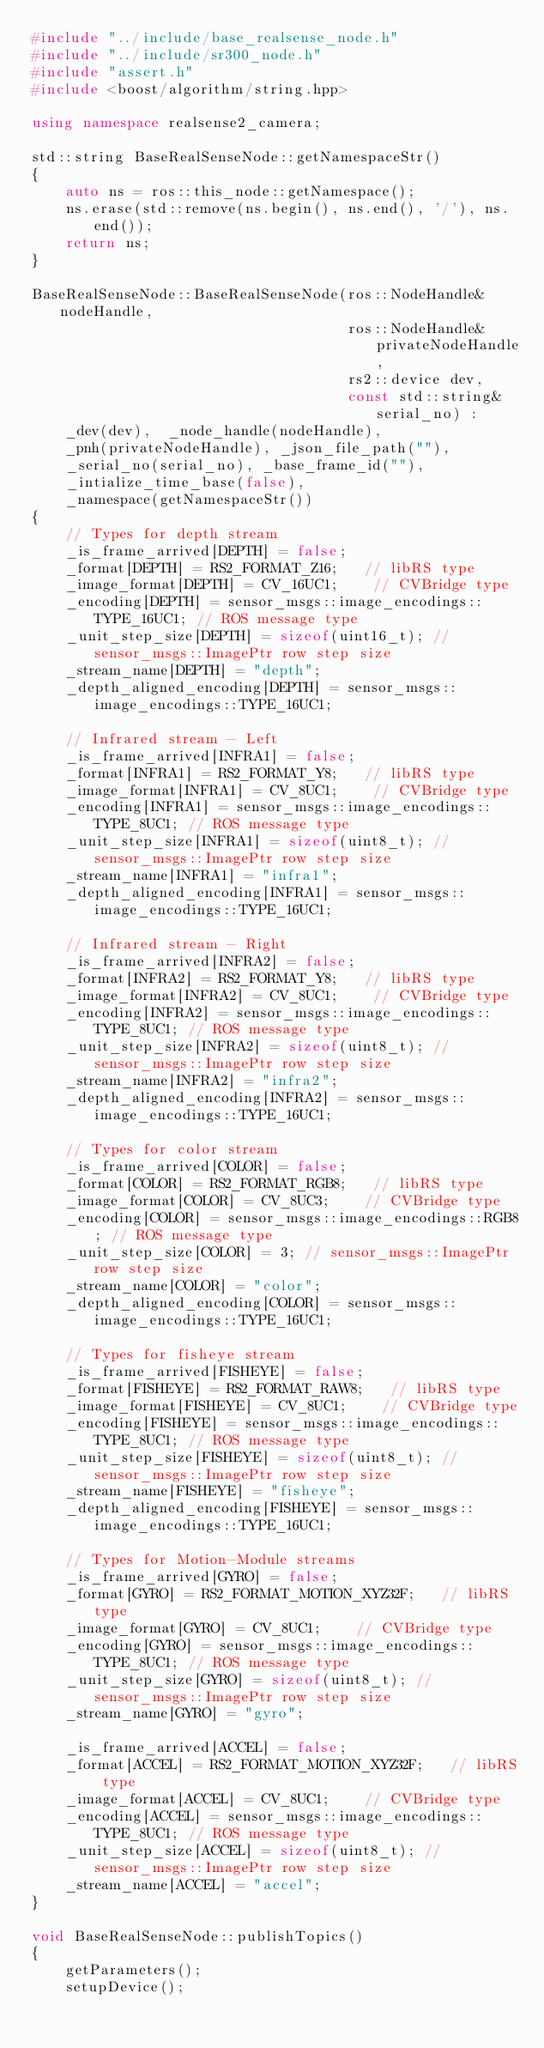<code> <loc_0><loc_0><loc_500><loc_500><_C++_>#include "../include/base_realsense_node.h"
#include "../include/sr300_node.h"
#include "assert.h"
#include <boost/algorithm/string.hpp>

using namespace realsense2_camera;

std::string BaseRealSenseNode::getNamespaceStr()
{
    auto ns = ros::this_node::getNamespace();
    ns.erase(std::remove(ns.begin(), ns.end(), '/'), ns.end());
    return ns;
}

BaseRealSenseNode::BaseRealSenseNode(ros::NodeHandle& nodeHandle,
                                     ros::NodeHandle& privateNodeHandle,
                                     rs2::device dev,
                                     const std::string& serial_no) :
    _dev(dev),  _node_handle(nodeHandle),
    _pnh(privateNodeHandle), _json_file_path(""),
    _serial_no(serial_no), _base_frame_id(""),
    _intialize_time_base(false),
    _namespace(getNamespaceStr())
{
    // Types for depth stream
    _is_frame_arrived[DEPTH] = false;
    _format[DEPTH] = RS2_FORMAT_Z16;   // libRS type
    _image_format[DEPTH] = CV_16UC1;    // CVBridge type
    _encoding[DEPTH] = sensor_msgs::image_encodings::TYPE_16UC1; // ROS message type
    _unit_step_size[DEPTH] = sizeof(uint16_t); // sensor_msgs::ImagePtr row step size
    _stream_name[DEPTH] = "depth";
    _depth_aligned_encoding[DEPTH] = sensor_msgs::image_encodings::TYPE_16UC1;

    // Infrared stream - Left
    _is_frame_arrived[INFRA1] = false;
    _format[INFRA1] = RS2_FORMAT_Y8;   // libRS type
    _image_format[INFRA1] = CV_8UC1;    // CVBridge type
    _encoding[INFRA1] = sensor_msgs::image_encodings::TYPE_8UC1; // ROS message type
    _unit_step_size[INFRA1] = sizeof(uint8_t); // sensor_msgs::ImagePtr row step size
    _stream_name[INFRA1] = "infra1";
    _depth_aligned_encoding[INFRA1] = sensor_msgs::image_encodings::TYPE_16UC1;

    // Infrared stream - Right
    _is_frame_arrived[INFRA2] = false;
    _format[INFRA2] = RS2_FORMAT_Y8;   // libRS type
    _image_format[INFRA2] = CV_8UC1;    // CVBridge type
    _encoding[INFRA2] = sensor_msgs::image_encodings::TYPE_8UC1; // ROS message type
    _unit_step_size[INFRA2] = sizeof(uint8_t); // sensor_msgs::ImagePtr row step size
    _stream_name[INFRA2] = "infra2";
    _depth_aligned_encoding[INFRA2] = sensor_msgs::image_encodings::TYPE_16UC1;

    // Types for color stream
    _is_frame_arrived[COLOR] = false;
    _format[COLOR] = RS2_FORMAT_RGB8;   // libRS type
    _image_format[COLOR] = CV_8UC3;    // CVBridge type
    _encoding[COLOR] = sensor_msgs::image_encodings::RGB8; // ROS message type
    _unit_step_size[COLOR] = 3; // sensor_msgs::ImagePtr row step size
    _stream_name[COLOR] = "color";
    _depth_aligned_encoding[COLOR] = sensor_msgs::image_encodings::TYPE_16UC1;

    // Types for fisheye stream
    _is_frame_arrived[FISHEYE] = false;
    _format[FISHEYE] = RS2_FORMAT_RAW8;   // libRS type
    _image_format[FISHEYE] = CV_8UC1;    // CVBridge type
    _encoding[FISHEYE] = sensor_msgs::image_encodings::TYPE_8UC1; // ROS message type
    _unit_step_size[FISHEYE] = sizeof(uint8_t); // sensor_msgs::ImagePtr row step size
    _stream_name[FISHEYE] = "fisheye";
    _depth_aligned_encoding[FISHEYE] = sensor_msgs::image_encodings::TYPE_16UC1;

    // Types for Motion-Module streams
    _is_frame_arrived[GYRO] = false;
    _format[GYRO] = RS2_FORMAT_MOTION_XYZ32F;   // libRS type
    _image_format[GYRO] = CV_8UC1;    // CVBridge type
    _encoding[GYRO] = sensor_msgs::image_encodings::TYPE_8UC1; // ROS message type
    _unit_step_size[GYRO] = sizeof(uint8_t); // sensor_msgs::ImagePtr row step size
    _stream_name[GYRO] = "gyro";

    _is_frame_arrived[ACCEL] = false;
    _format[ACCEL] = RS2_FORMAT_MOTION_XYZ32F;   // libRS type
    _image_format[ACCEL] = CV_8UC1;    // CVBridge type
    _encoding[ACCEL] = sensor_msgs::image_encodings::TYPE_8UC1; // ROS message type
    _unit_step_size[ACCEL] = sizeof(uint8_t); // sensor_msgs::ImagePtr row step size
    _stream_name[ACCEL] = "accel";
}

void BaseRealSenseNode::publishTopics()
{
    getParameters();
    setupDevice();</code> 